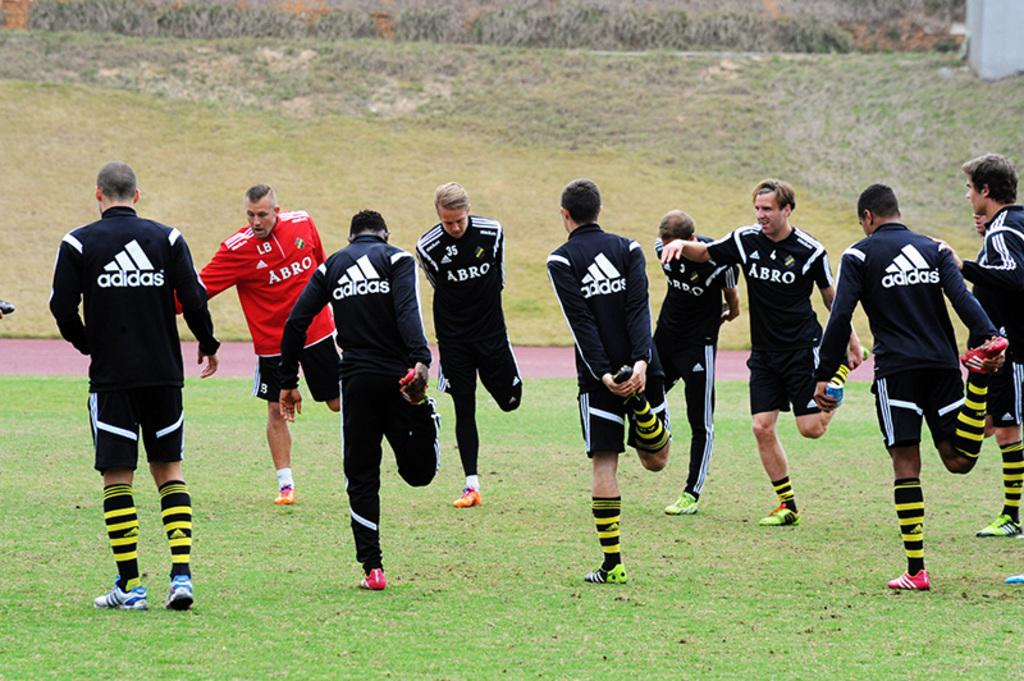<image>
Relay a brief, clear account of the picture shown. A men's soccer team wearing Adidas and Abro jerseys 